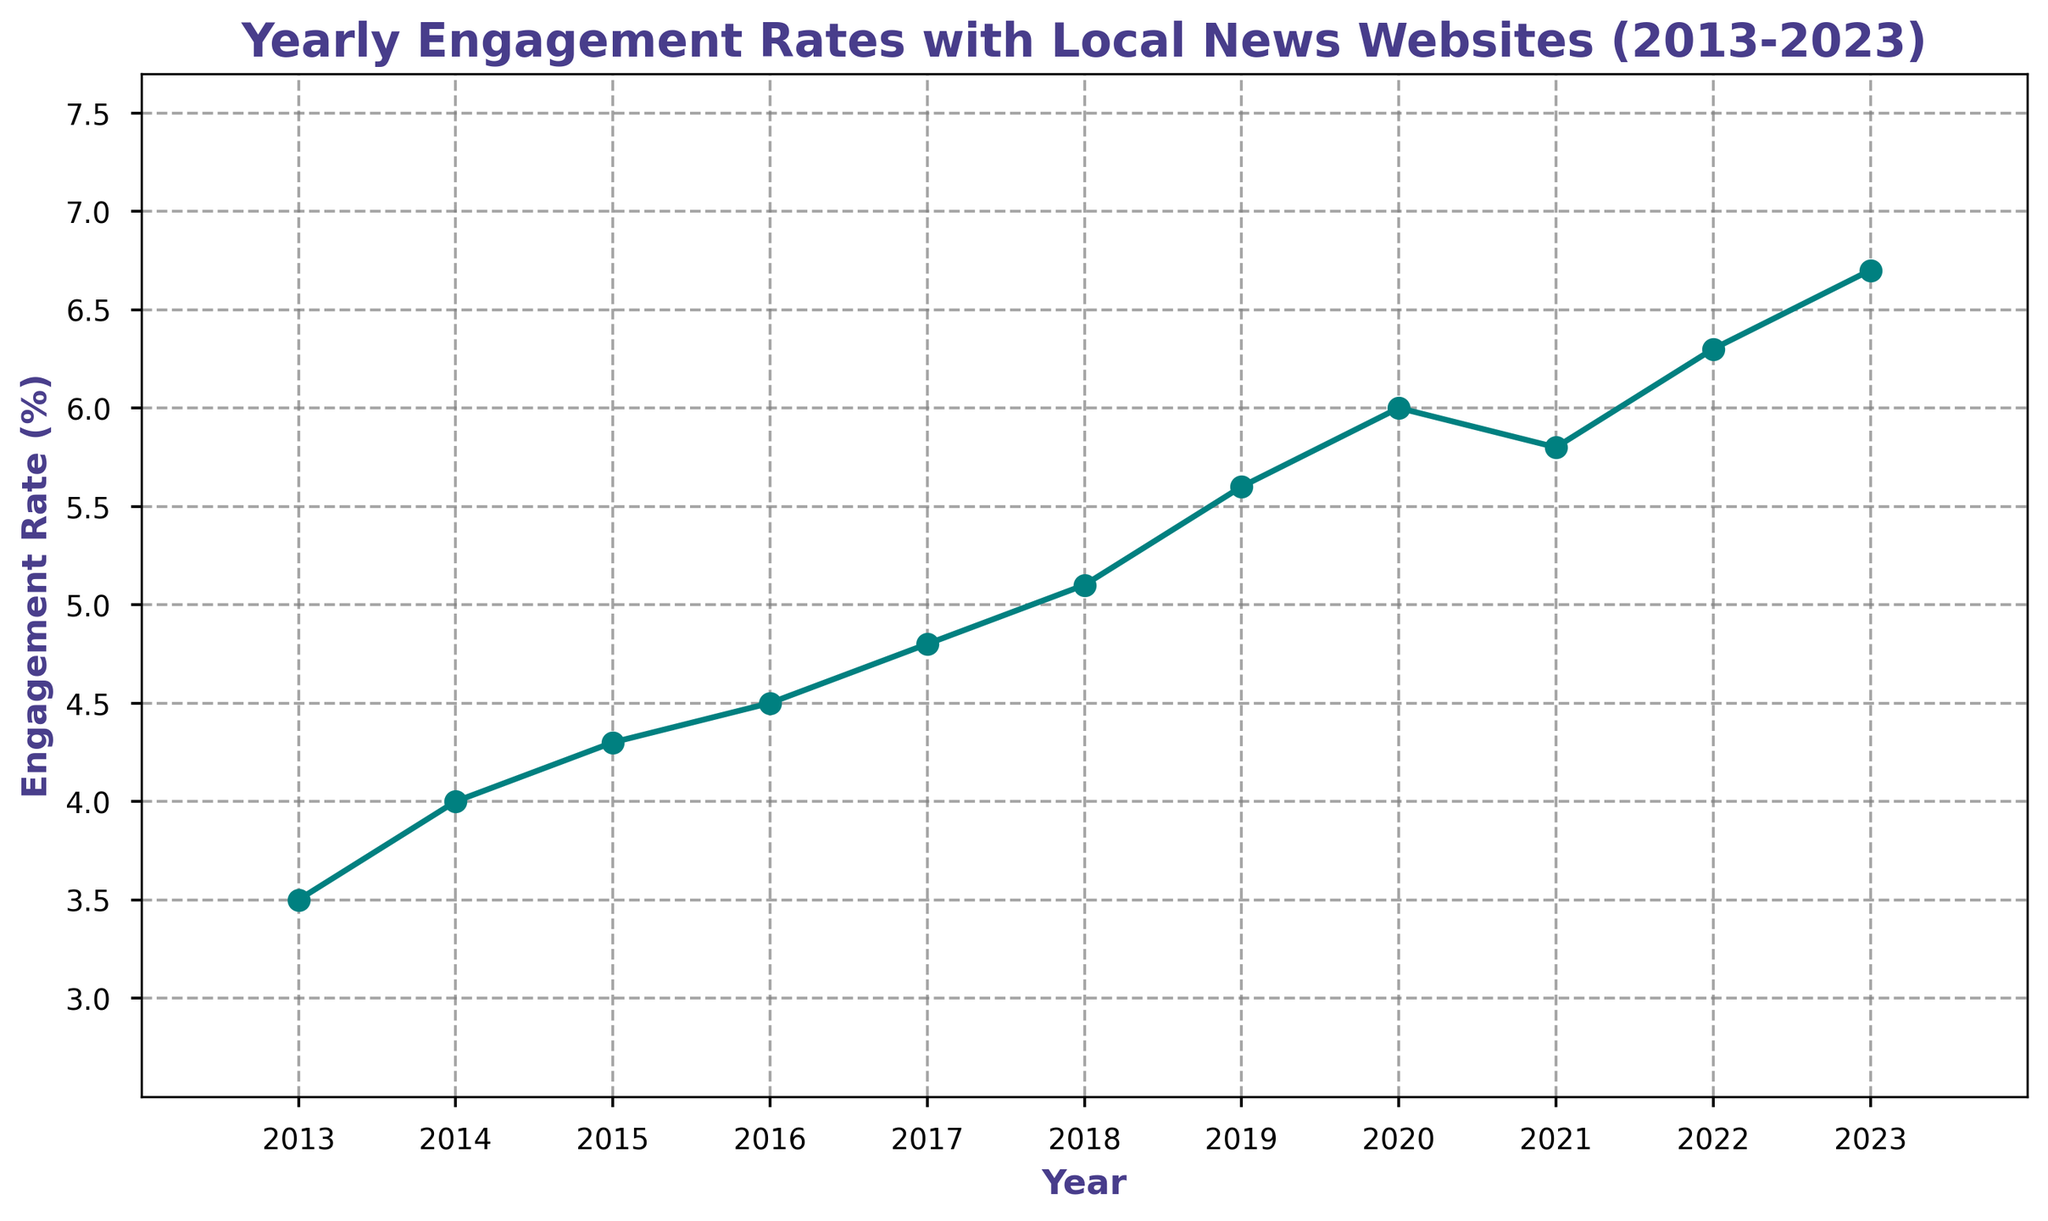What's the engagement rate trend from 2013 to 2023? The engagement rate shows a generally increasing trend from 2013 to 2023. The rate rises from 3.5% in 2013 to 6.7% in 2023 with a slight dip in 2021.
Answer: Increasing In which year did the engagement rate experience the highest increase from the previous year? Compare the differences in engagement rates between consecutive years: (4.0 - 3.5) = 0.5, (4.3 - 4.0) = 0.3, (4.5 - 4.3) = 0.2, (4.8 - 4.5) = 0.3, (5.1 - 4.8) = 0.3, (5.6 - 5.1) = 0.5, (6.0 - 5.6) = 0.4, (5.8 - 6.0) = -0.2, (6.3 - 5.8) = 0.5, and (6.7 - 6.3) = 0.4. The highest increase is 0.5 which happens between 2013-2014, 2018-2019, and 2021-2022.
Answer: 2014, 2019, 2022 How does the engagement rate in 2020 compare to the rate in 2018? In 2018, the engagement rate was 5.1%, and in 2020, it was 6.0%. This indicates that the engagement rate in 2020 is higher than in 2018.
Answer: Higher What is the average engagement rate over the 10-year period from 2013 to 2023? Sum up all the engagement rates from 2013 to 2023 and divide by the number of years: (3.5 + 4.0 + 4.3 + 4.5 + 4.8 + 5.1 + 5.6 + 6.0 + 5.8 + 6.3 + 6.7)/11. This sums up to 56.6, and dividing by 11 gives approximately 5.145.
Answer: 5.145 Find the difference in engagement rate between the highest and lowest years. Identify the highest engagement rate (6.7% in 2023) and the lowest (3.5% in 2013). Subtract the lowest from the highest: 6.7 - 3.5 = 3.2.
Answer: 3.2 Did the engagement rate ever decrease from one year to the next? If so, when? Review each year's engagement rate and compare it to the previous year. The only decrease is spotted from 2020 (6.0%) to 2021 (5.8%).
Answer: Yes, 2021 Which year marks the midpoint of the dataset, and what is the engagement rate in that year? The dataset spans 11 years, so the midpoint is the 6th year. Counting from 2013, the 6th year is 2018. The engagement rate in 2018 is 5.1%.
Answer: 2018, 5.1 What is the total increment in engagement rate from 2013 to 2023? Subtract the engagement rate in 2013 from that in 2023: 6.7 (2023) - 3.5 (2013) = 3.2.
Answer: 3.2 